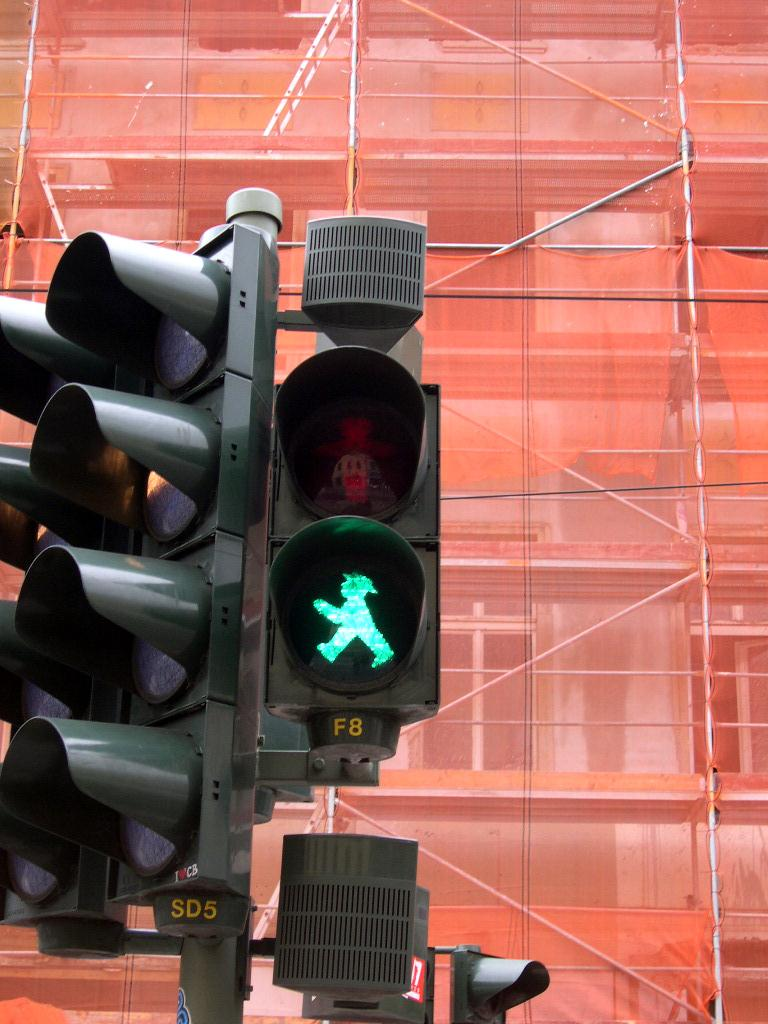<image>
Describe the image concisely. A green crosswalk light with F8 painted below it. 